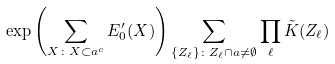<formula> <loc_0><loc_0><loc_500><loc_500>\exp \left ( \sum _ { X \colon X \subset \L a ^ { c } } E ^ { \prime } _ { 0 } ( X ) \right ) \sum _ { \{ Z _ { \ell } \} \colon Z _ { \ell } \cap \L a \neq \emptyset } \prod _ { \ell } \tilde { K } ( Z _ { \ell } )</formula> 